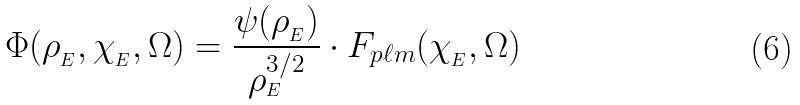Convert formula to latex. <formula><loc_0><loc_0><loc_500><loc_500>\Phi ( \rho _ { _ { E } } , \chi _ { _ { E } } , \Omega ) = \frac { \psi ( \rho _ { _ { E } } ) } { \rho ^ { 3 / 2 } _ { _ { E } } } \cdot F _ { p \ell m } ( \chi _ { _ { E } } , \Omega )</formula> 